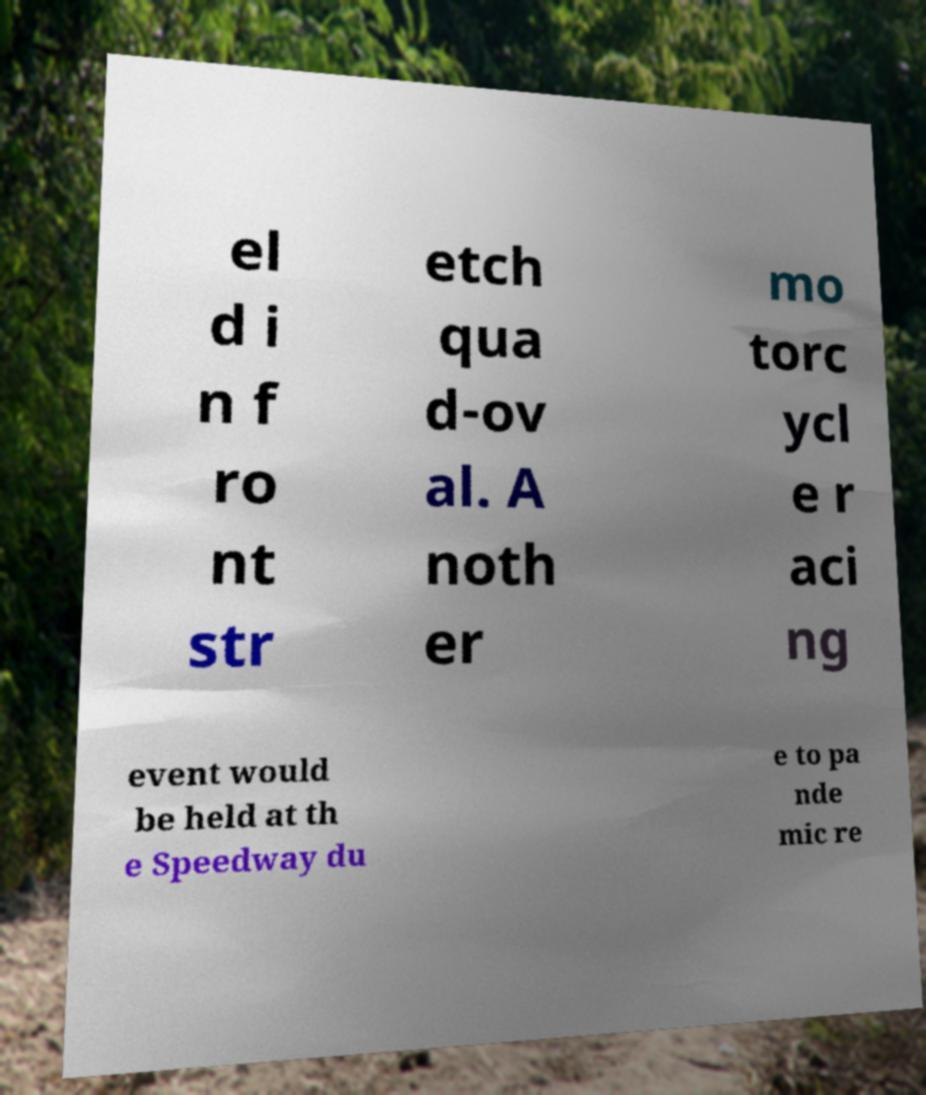Could you extract and type out the text from this image? el d i n f ro nt str etch qua d-ov al. A noth er mo torc ycl e r aci ng event would be held at th e Speedway du e to pa nde mic re 